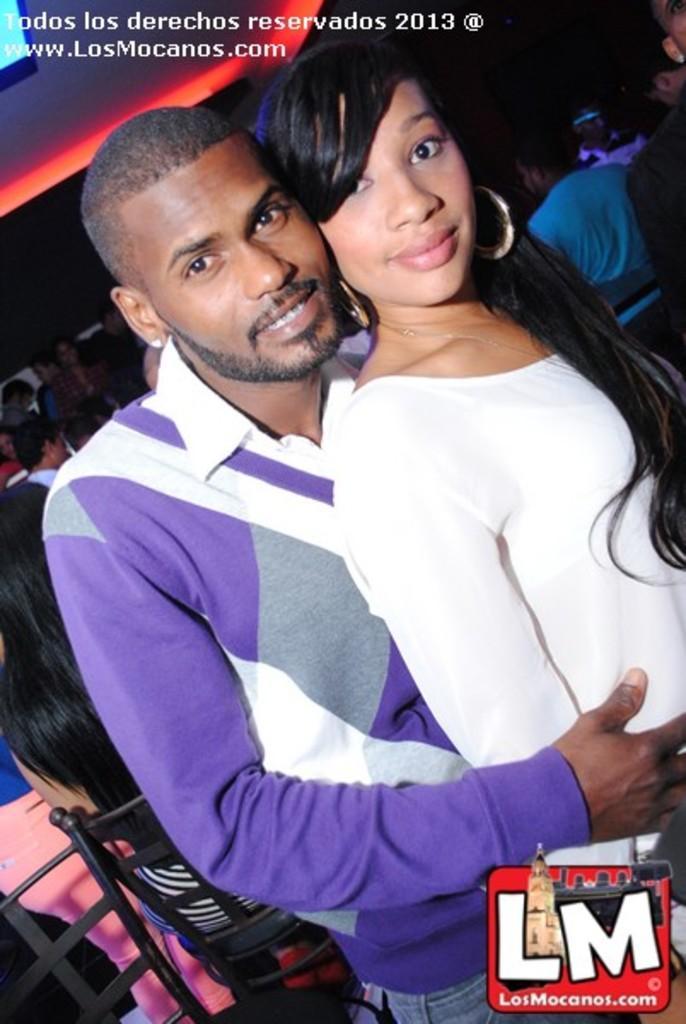Please provide a concise description of this image. In this picture, we see the man and the women are standing. They are smiling and they are posing for the photo. Behind them, we see a woman is sitting on the chair. In the background, we see the people. In the right top, we see a man in the blue T-shirt is sitting on the chair. In the background, it is black in color. In the left top, we see the lights and the television screen. This picture is clicked in the dark. 